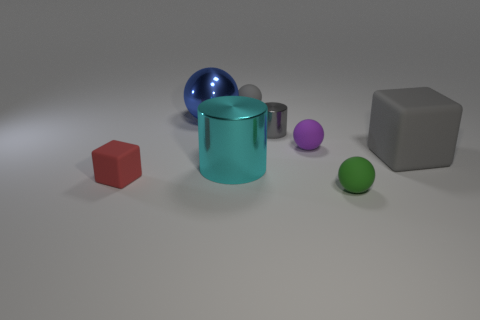What size is the blue thing that is made of the same material as the large cyan thing?
Make the answer very short. Large. There is a gray object behind the blue object that is behind the gray metal object; what number of green things are behind it?
Your answer should be compact. 0. There is a small matte cube; does it have the same color as the object that is in front of the tiny matte cube?
Provide a succinct answer. No. What is the shape of the other tiny object that is the same color as the tiny shiny thing?
Ensure brevity in your answer.  Sphere. What material is the cylinder in front of the rubber block to the right of the gray matte object that is behind the tiny purple rubber sphere made of?
Your answer should be very brief. Metal. There is a gray thing behind the blue shiny object; does it have the same shape as the red thing?
Keep it short and to the point. No. What material is the large object that is to the right of the cyan cylinder?
Your answer should be compact. Rubber. How many rubber objects are either large gray cubes or tiny green things?
Your answer should be very brief. 2. Are there any brown balls of the same size as the red block?
Provide a succinct answer. No. Is the number of tiny metal things left of the small matte block greater than the number of small gray balls?
Your response must be concise. No. 